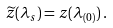<formula> <loc_0><loc_0><loc_500><loc_500>\widetilde { z } ( \lambda _ { s } ) = z ( \lambda _ { ( 0 ) } ) \, .</formula> 